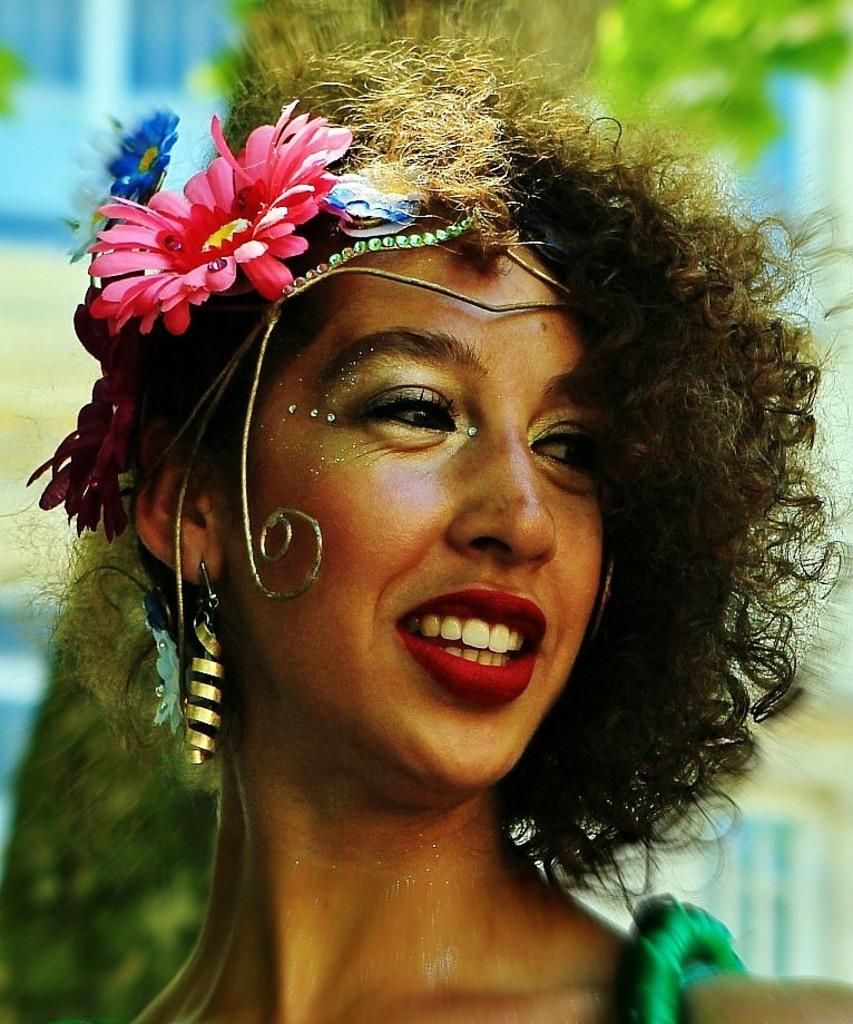What is the main subject of the image? The main subject of the image is a girl's face. What accessories is the girl wearing in the image? The girl is wearing earrings and a flower wreath in the image. What type of jam is the girl spreading on the bread in the image? There is no jam or bread present in the image; it only features the girl's face with earrings and a flower wreath. What activity is the girl participating in while wearing the earrings and flower wreath? The image does not show the girl participating in any activity; it only shows her face with the accessories. 